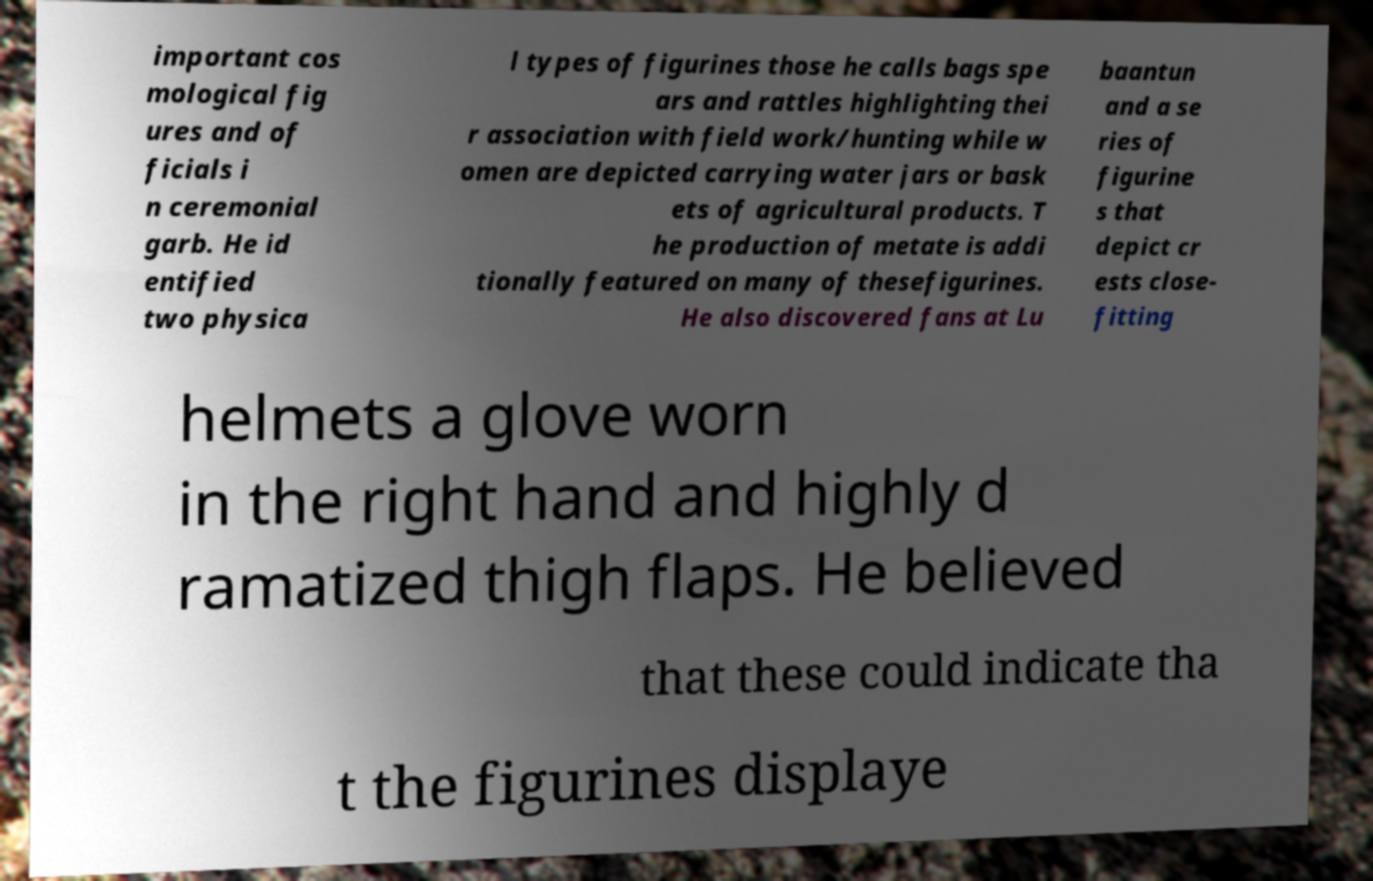Can you accurately transcribe the text from the provided image for me? important cos mological fig ures and of ficials i n ceremonial garb. He id entified two physica l types of figurines those he calls bags spe ars and rattles highlighting thei r association with field work/hunting while w omen are depicted carrying water jars or bask ets of agricultural products. T he production of metate is addi tionally featured on many of thesefigurines. He also discovered fans at Lu baantun and a se ries of figurine s that depict cr ests close- fitting helmets a glove worn in the right hand and highly d ramatized thigh flaps. He believed that these could indicate tha t the figurines displaye 